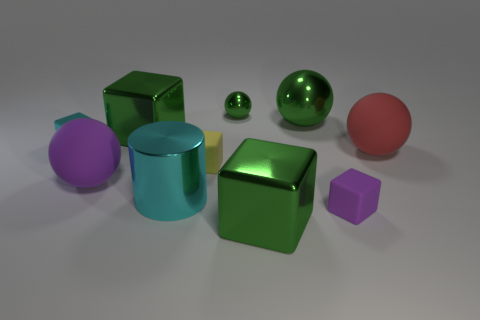Subtract all yellow blocks. How many blocks are left? 4 Subtract all purple cubes. How many cubes are left? 4 Subtract all red cylinders. Subtract all yellow blocks. How many cylinders are left? 1 Subtract all cylinders. How many objects are left? 9 Add 3 yellow rubber things. How many yellow rubber things exist? 4 Subtract 0 gray cylinders. How many objects are left? 10 Subtract all small shiny things. Subtract all tiny green shiny things. How many objects are left? 7 Add 6 purple matte cubes. How many purple matte cubes are left? 7 